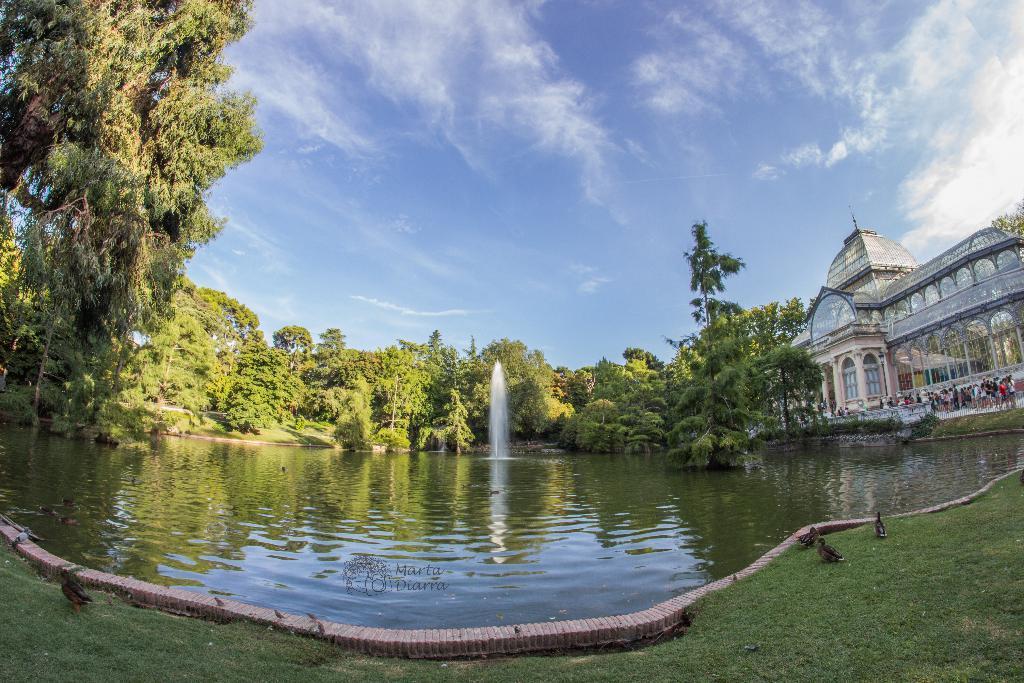Please provide a concise description of this image. There is grass at the front and birds are present. There is water and there is a fountain and trees at the back. There is a building and people are present at the right back. There is sky at the top. 